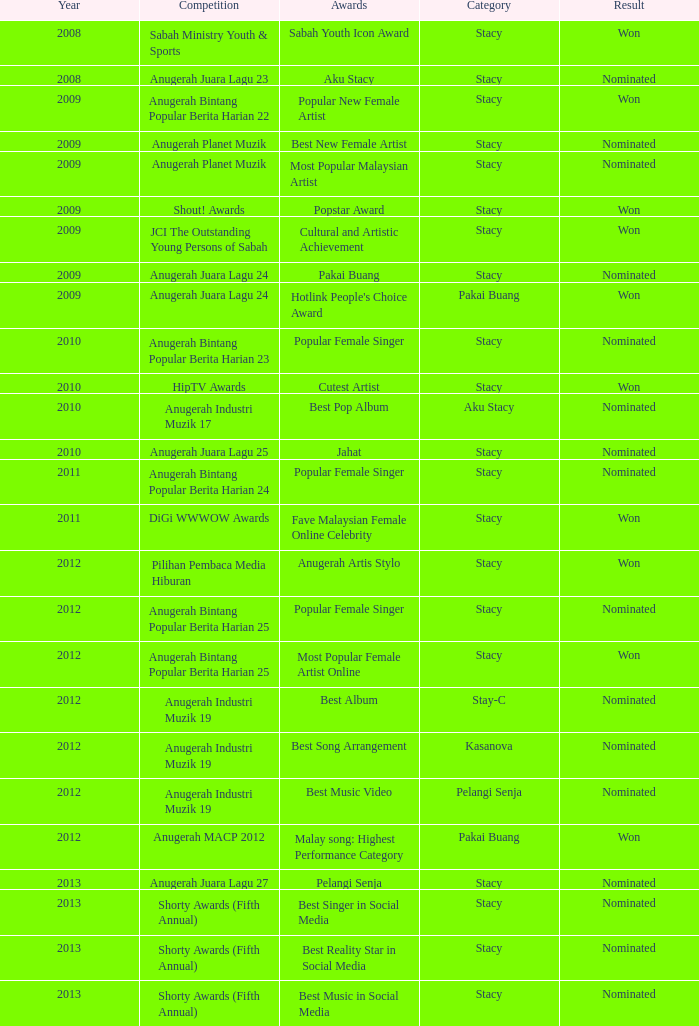During which year was anugerah bintang popular berita harian 23 held as a contest? 1.0. 